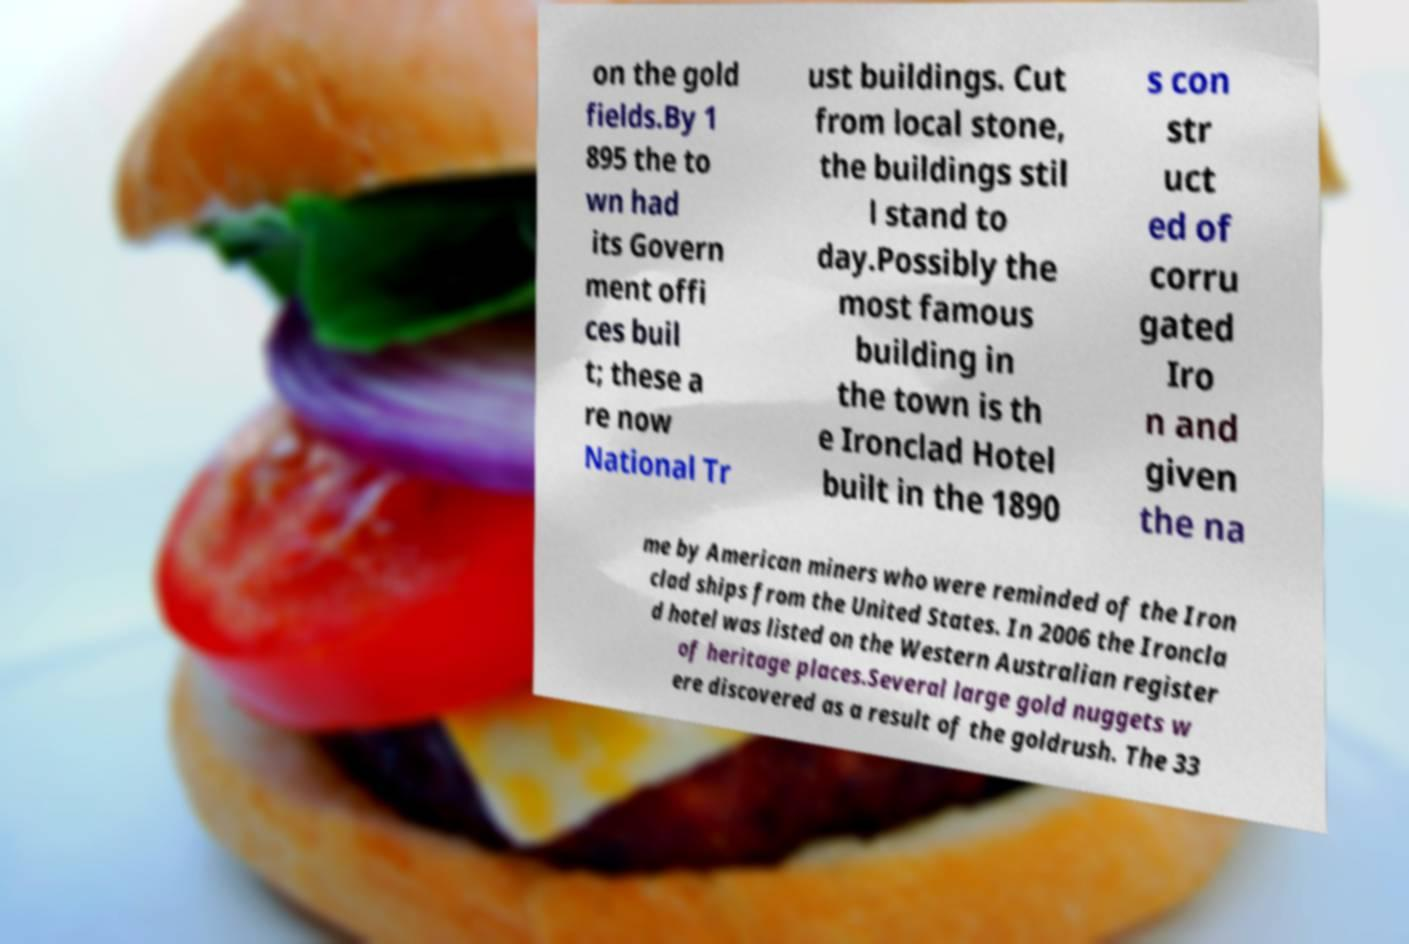For documentation purposes, I need the text within this image transcribed. Could you provide that? on the gold fields.By 1 895 the to wn had its Govern ment offi ces buil t; these a re now National Tr ust buildings. Cut from local stone, the buildings stil l stand to day.Possibly the most famous building in the town is th e Ironclad Hotel built in the 1890 s con str uct ed of corru gated Iro n and given the na me by American miners who were reminded of the Iron clad ships from the United States. In 2006 the Ironcla d hotel was listed on the Western Australian register of heritage places.Several large gold nuggets w ere discovered as a result of the goldrush. The 33 